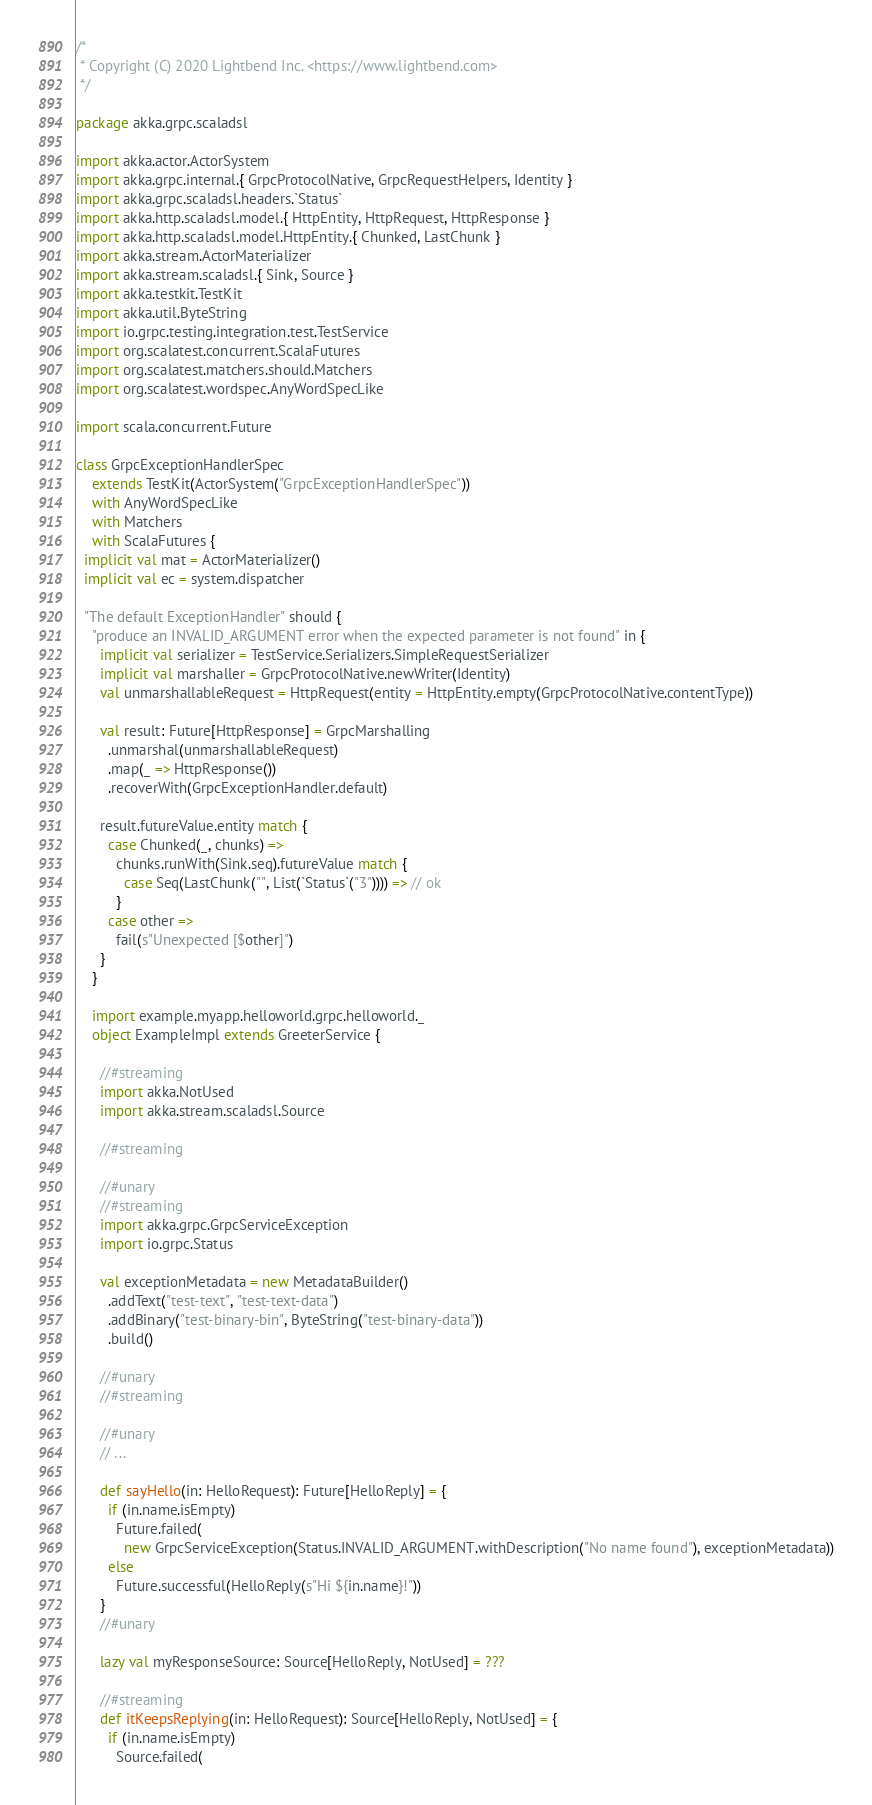<code> <loc_0><loc_0><loc_500><loc_500><_Scala_>/*
 * Copyright (C) 2020 Lightbend Inc. <https://www.lightbend.com>
 */

package akka.grpc.scaladsl

import akka.actor.ActorSystem
import akka.grpc.internal.{ GrpcProtocolNative, GrpcRequestHelpers, Identity }
import akka.grpc.scaladsl.headers.`Status`
import akka.http.scaladsl.model.{ HttpEntity, HttpRequest, HttpResponse }
import akka.http.scaladsl.model.HttpEntity.{ Chunked, LastChunk }
import akka.stream.ActorMaterializer
import akka.stream.scaladsl.{ Sink, Source }
import akka.testkit.TestKit
import akka.util.ByteString
import io.grpc.testing.integration.test.TestService
import org.scalatest.concurrent.ScalaFutures
import org.scalatest.matchers.should.Matchers
import org.scalatest.wordspec.AnyWordSpecLike

import scala.concurrent.Future

class GrpcExceptionHandlerSpec
    extends TestKit(ActorSystem("GrpcExceptionHandlerSpec"))
    with AnyWordSpecLike
    with Matchers
    with ScalaFutures {
  implicit val mat = ActorMaterializer()
  implicit val ec = system.dispatcher

  "The default ExceptionHandler" should {
    "produce an INVALID_ARGUMENT error when the expected parameter is not found" in {
      implicit val serializer = TestService.Serializers.SimpleRequestSerializer
      implicit val marshaller = GrpcProtocolNative.newWriter(Identity)
      val unmarshallableRequest = HttpRequest(entity = HttpEntity.empty(GrpcProtocolNative.contentType))

      val result: Future[HttpResponse] = GrpcMarshalling
        .unmarshal(unmarshallableRequest)
        .map(_ => HttpResponse())
        .recoverWith(GrpcExceptionHandler.default)

      result.futureValue.entity match {
        case Chunked(_, chunks) =>
          chunks.runWith(Sink.seq).futureValue match {
            case Seq(LastChunk("", List(`Status`("3")))) => // ok
          }
        case other =>
          fail(s"Unexpected [$other]")
      }
    }

    import example.myapp.helloworld.grpc.helloworld._
    object ExampleImpl extends GreeterService {

      //#streaming
      import akka.NotUsed
      import akka.stream.scaladsl.Source

      //#streaming

      //#unary
      //#streaming
      import akka.grpc.GrpcServiceException
      import io.grpc.Status

      val exceptionMetadata = new MetadataBuilder()
        .addText("test-text", "test-text-data")
        .addBinary("test-binary-bin", ByteString("test-binary-data"))
        .build()

      //#unary
      //#streaming

      //#unary
      // ...

      def sayHello(in: HelloRequest): Future[HelloReply] = {
        if (in.name.isEmpty)
          Future.failed(
            new GrpcServiceException(Status.INVALID_ARGUMENT.withDescription("No name found"), exceptionMetadata))
        else
          Future.successful(HelloReply(s"Hi ${in.name}!"))
      }
      //#unary

      lazy val myResponseSource: Source[HelloReply, NotUsed] = ???

      //#streaming
      def itKeepsReplying(in: HelloRequest): Source[HelloReply, NotUsed] = {
        if (in.name.isEmpty)
          Source.failed(</code> 